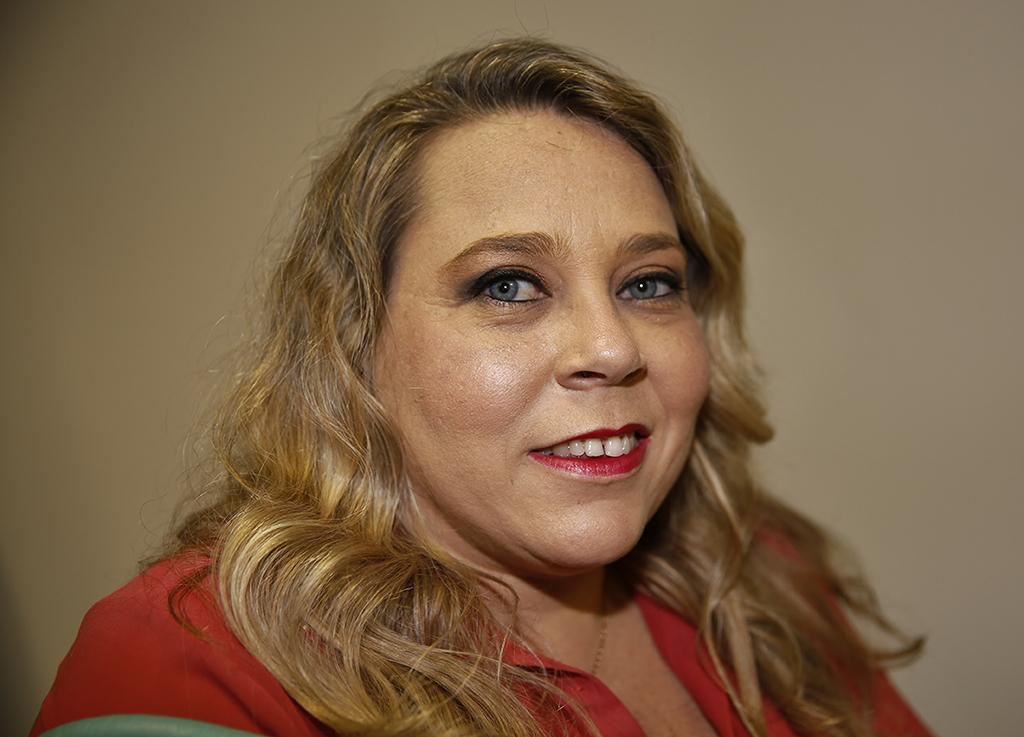Who is the main subject in the image? There is a woman in the center of the image. How many stitches are visible on the woman's clothing in the image? There is no information about the woman's clothing or any stitches in the provided fact, so we cannot answer this question. 